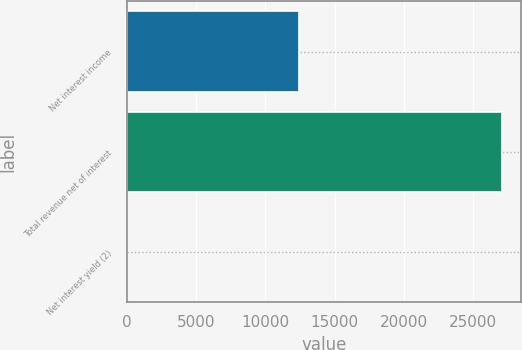Convert chart. <chart><loc_0><loc_0><loc_500><loc_500><bar_chart><fcel>Net interest income<fcel>Total revenue net of interest<fcel>Net interest yield (2)<nl><fcel>12397<fcel>27095<fcel>2.67<nl></chart> 